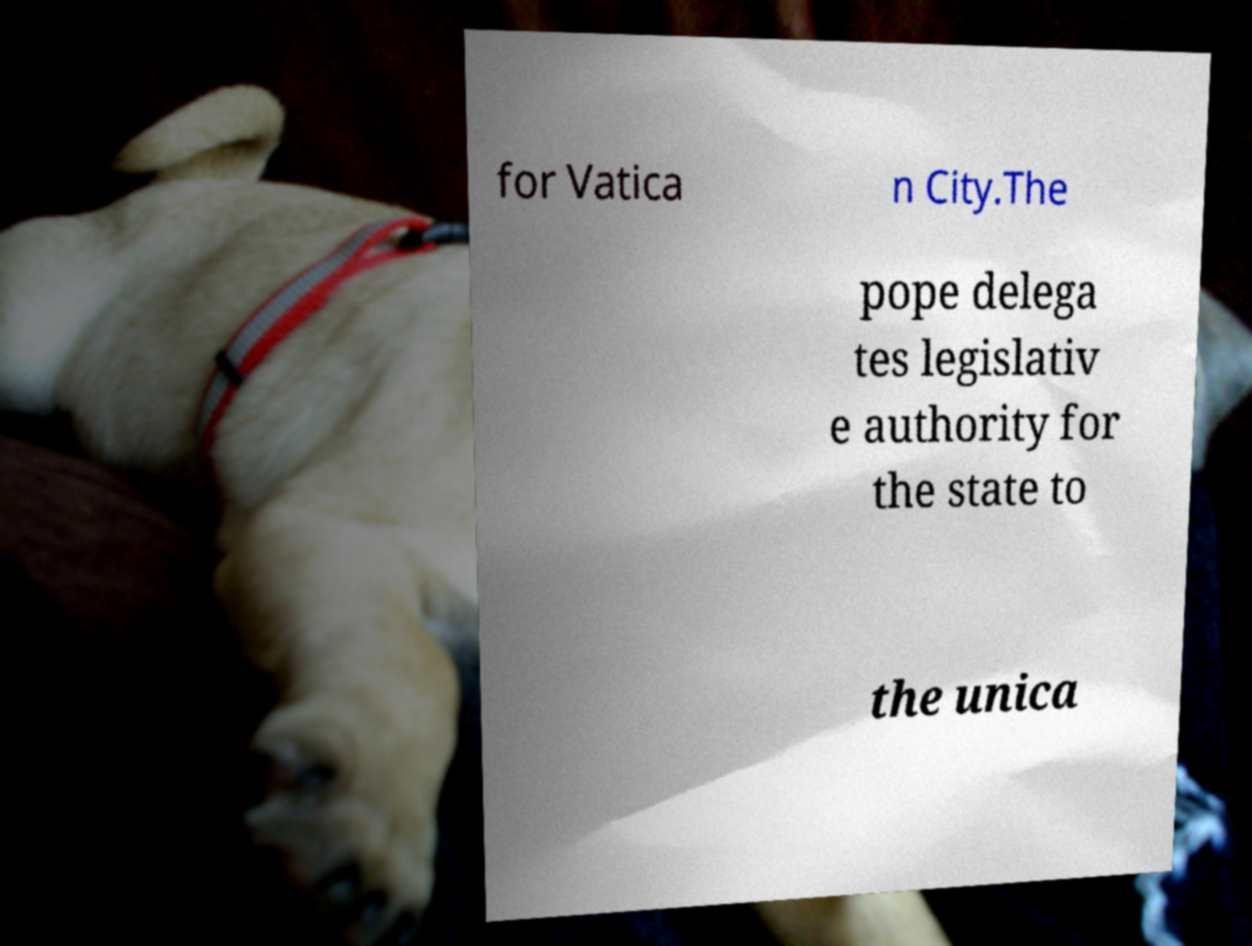Please read and relay the text visible in this image. What does it say? for Vatica n City.The pope delega tes legislativ e authority for the state to the unica 